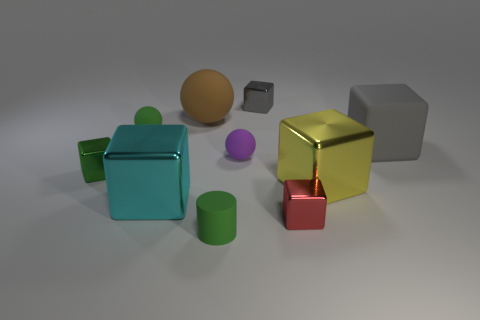There is a tiny metal object that is the same color as the matte cube; what shape is it?
Offer a terse response. Cube. There is a tiny rubber object behind the gray rubber object; is its color the same as the small thing that is left of the green rubber ball?
Keep it short and to the point. Yes. The big rubber thing that is the same shape as the small red metal thing is what color?
Your answer should be compact. Gray. Are there any other things that have the same shape as the large cyan metallic object?
Your answer should be compact. Yes. Are there the same number of big matte things in front of the green matte cylinder and big green cubes?
Offer a terse response. Yes. There is a big cyan metal object; are there any large yellow objects on the right side of it?
Offer a terse response. Yes. How big is the matte object right of the small metallic cube in front of the big metallic block that is left of the tiny red shiny object?
Keep it short and to the point. Large. There is a green rubber object that is behind the purple rubber ball; is its shape the same as the small matte thing that is in front of the cyan metallic object?
Ensure brevity in your answer.  No. There is a green object that is the same shape as the gray matte thing; what is its size?
Your response must be concise. Small. What number of green balls have the same material as the big brown object?
Keep it short and to the point. 1. 